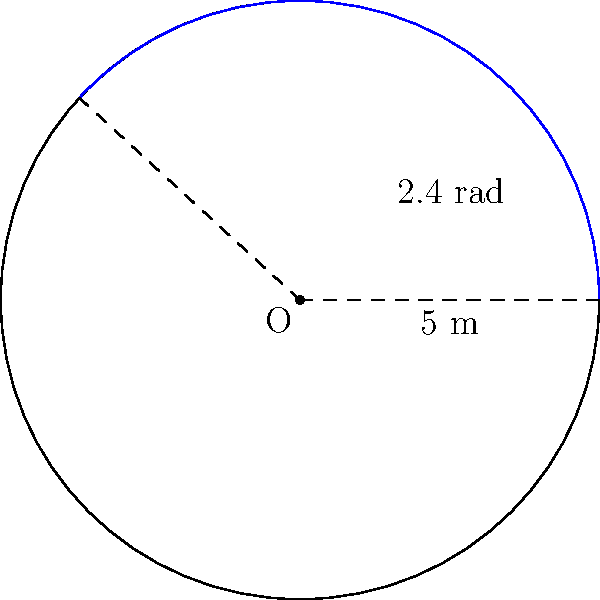At the Paradise Island Resort, a circular cruise ship pool has a radius of 5 meters. A guest wants to relax in a section of the pool that forms a sector with a central angle of 2.4 radians. What is the area of this sector of the pool? Let's approach this step-by-step:

1) The formula for the area of a sector is:

   $$ A = \frac{1}{2} r^2 \theta $$

   where $A$ is the area, $r$ is the radius, and $\theta$ is the central angle in radians.

2) We are given:
   - Radius $r = 5$ meters
   - Central angle $\theta = 2.4$ radians

3) Let's substitute these values into our formula:

   $$ A = \frac{1}{2} (5\text{ m})^2 (2.4\text{ rad}) $$

4) Simplify:
   $$ A = \frac{1}{2} (25\text{ m}^2) (2.4\text{ rad}) $$
   $$ A = 12.5\text{ m}^2 \cdot 2.4\text{ rad} $$
   $$ A = 30\text{ m}^2 $$

5) Therefore, the area of the sector is 30 square meters.
Answer: $30\text{ m}^2$ 